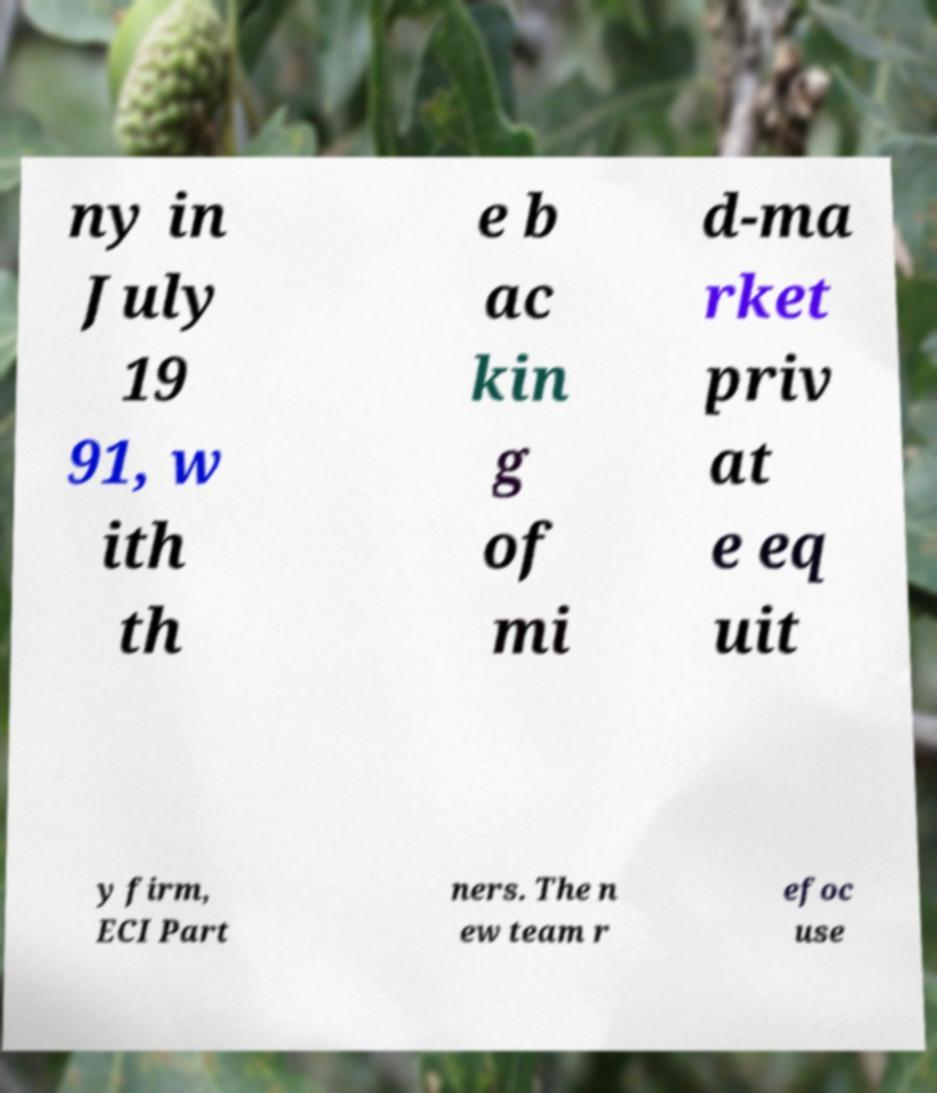There's text embedded in this image that I need extracted. Can you transcribe it verbatim? ny in July 19 91, w ith th e b ac kin g of mi d-ma rket priv at e eq uit y firm, ECI Part ners. The n ew team r efoc use 